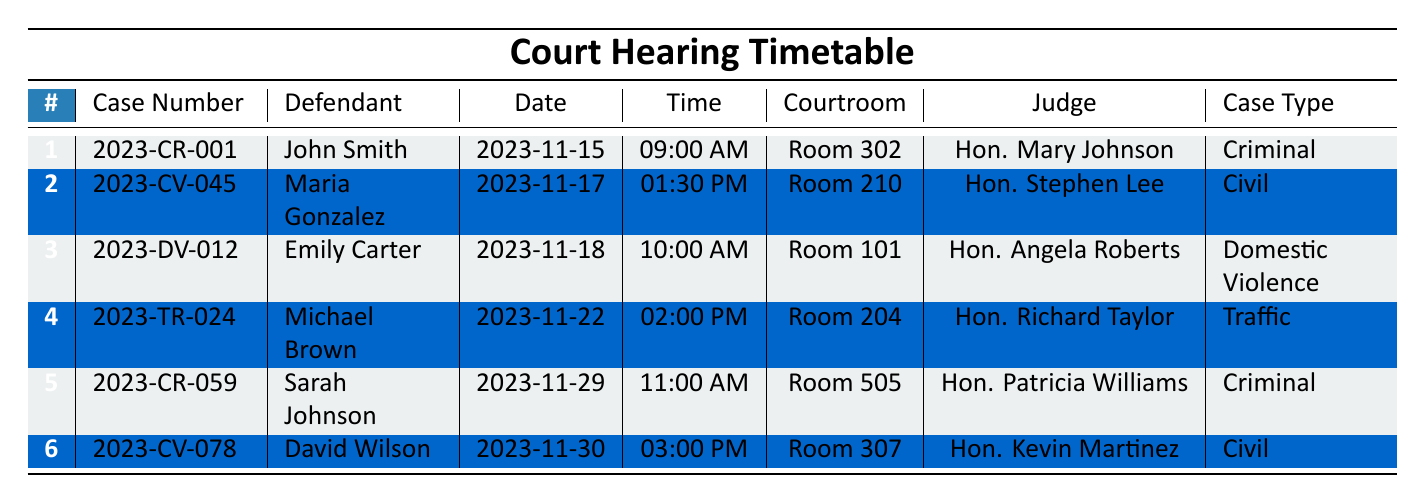What is the hearing date for John Smith's case? The table shows that the case number "2023-CR-001" corresponds to John Smith, with a hearing date listed as "2023-11-15".
Answer: 2023-11-15 In which courtroom will the hearing for Maria Gonzalez take place? The table indicates that Maria Gonzalez is associated with case number "2023-CV-045", and her hearing will occur in "Room 210".
Answer: Room 210 Is Emily Carter's case a criminal case? By looking at the case information for Emily Carter, whose case number is "2023-DV-012", the case type is listed as "Domestic Violence", meaning it is not a criminal case.
Answer: No How many civil cases are scheduled for November? From the table, there are two entries for civil cases: "2023-CV-045" (Maria Gonzalez on 2023-11-17) and "2023-CV-078" (David Wilson on 2023-11-30). Summing these entries, we find there are 2 civil cases.
Answer: 2 What time does the hearing for Michael Brown start? Michael Brown's case number is "2023-TR-024", and the table shows that his hearing is scheduled for "02:00 PM".
Answer: 02:00 PM Which judge will preside over the hearing for the case involving Sarah Johnson? The table indicates that Sarah Johnson, case number "2023-CR-059", will have her hearing presided over by "Hon. Patricia Williams".
Answer: Hon. Patricia Williams What is the difference in time between the hearings for Emily Carter and Sarah Johnson? The hearing for Emily Carter is set for "10:00 AM," while Sarah Johnson's is at "11:00 AM." Calculating the difference, 11:00 AM - 10:00 AM equals 1 hour.
Answer: 1 hour How many different judges are involved in the hearings listed? The table lists judges: Hon. Mary Johnson, Hon. Stephen Lee, Hon. Angela Roberts, Hon. Richard Taylor, and Hon. Patricia Williams, totaling five different judges involved in six cases.
Answer: 5 Is there a case scheduled for the same day as Thanksgiving? Thanksgiving falls on November 23, 2023, and reviewing the timetable, the next closest case is scheduled for November 22, 2023, for Michael Brown, indicating there is a case the day before Thanksgiving.
Answer: Yes Which defendant's hearing is the latest in the month of November? The latest hearing in November is for David Wilson, case number "2023-CV-078", scheduled for "2023-11-30" at "03:00 PM".
Answer: David Wilson 